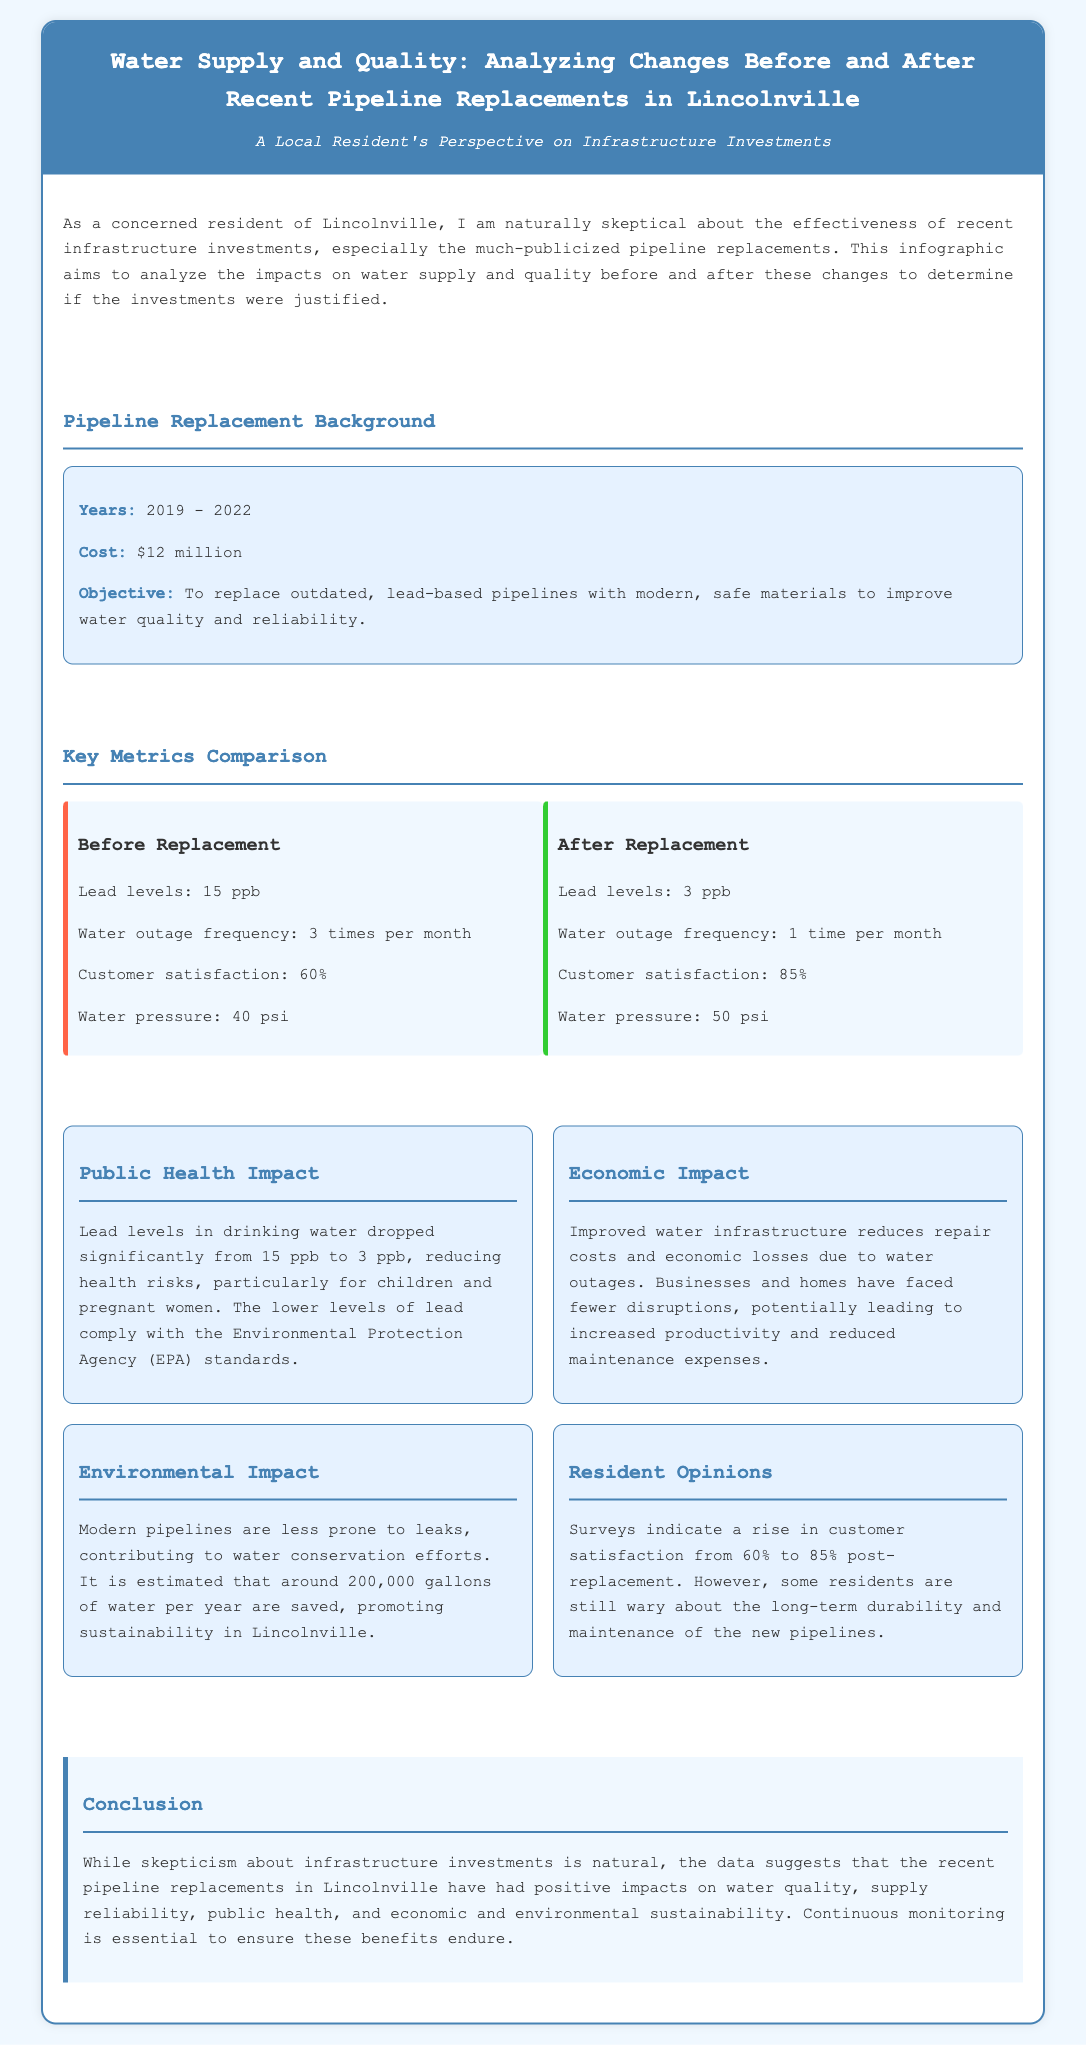what was the cost of the pipeline replacements? The cost is stated in the background section of the infographic, which is $12 million.
Answer: $12 million what led to improved customer satisfaction? The infographic mentions a rise in customer satisfaction from 60% to 85% after the pipeline replacements, indicating improved water quality and supply reliability.
Answer: Improved water quality what was the lead level before the pipeline replacement? Before the replacement, the lead levels were listed as 15 ppb in the key metrics comparison section.
Answer: 15 ppb how many times did water outages occur per month before replacement? The document states that water outages occurred 3 times per month before the replacement.
Answer: 3 times what percentage of residents were satisfied after the replacement? Post-replacement, customer satisfaction was noted to be 85%, as shown in the key metrics comparison.
Answer: 85% how much water is estimated to be saved per year due to the new pipelines? The environmental impact section states that around 200,000 gallons of water per year are estimated to be saved with the new pipelines.
Answer: 200,000 gallons what is the objective of the pipeline replacements? The objective is mentioned in the background section of the infographic, which is to replace outdated, lead-based pipelines with modern, safe materials.
Answer: Improve water quality what was the frequency of water outages after the replacement? After the replacement, the frequency of water outages is stated as 1 time per month.
Answer: 1 time 